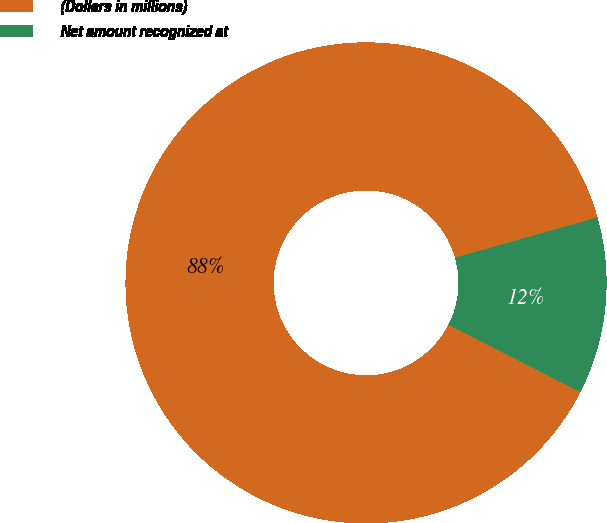Convert chart to OTSL. <chart><loc_0><loc_0><loc_500><loc_500><pie_chart><fcel>(Dollars in millions)<fcel>Net amount recognized at<nl><fcel>88.13%<fcel>11.87%<nl></chart> 